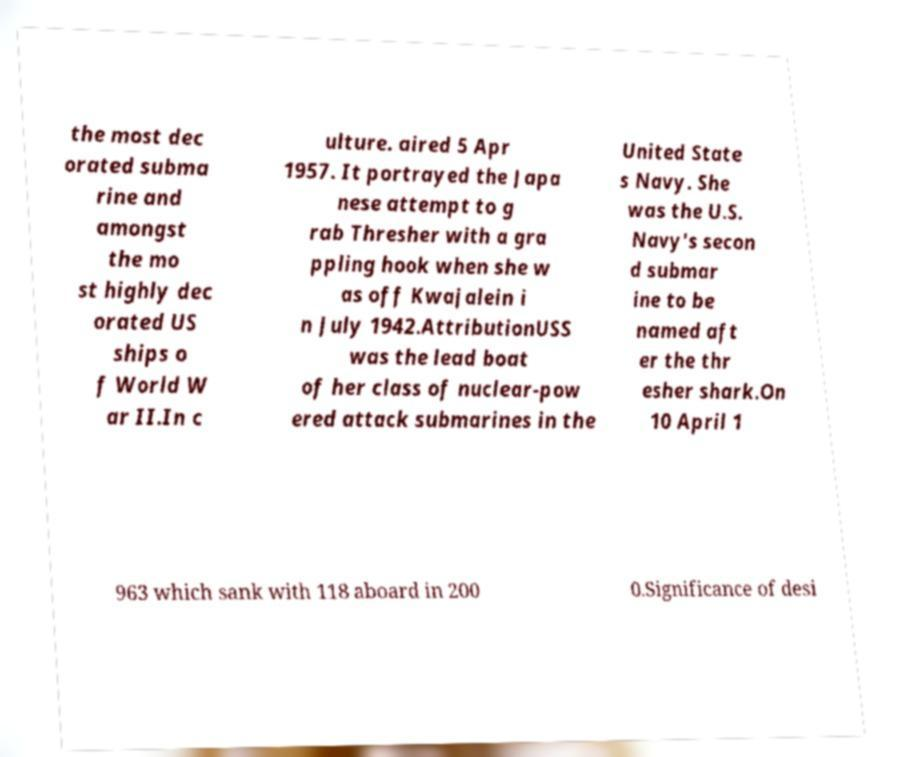Could you assist in decoding the text presented in this image and type it out clearly? the most dec orated subma rine and amongst the mo st highly dec orated US ships o f World W ar II.In c ulture. aired 5 Apr 1957. It portrayed the Japa nese attempt to g rab Thresher with a gra ppling hook when she w as off Kwajalein i n July 1942.AttributionUSS was the lead boat of her class of nuclear-pow ered attack submarines in the United State s Navy. She was the U.S. Navy's secon d submar ine to be named aft er the thr esher shark.On 10 April 1 963 which sank with 118 aboard in 200 0.Significance of desi 